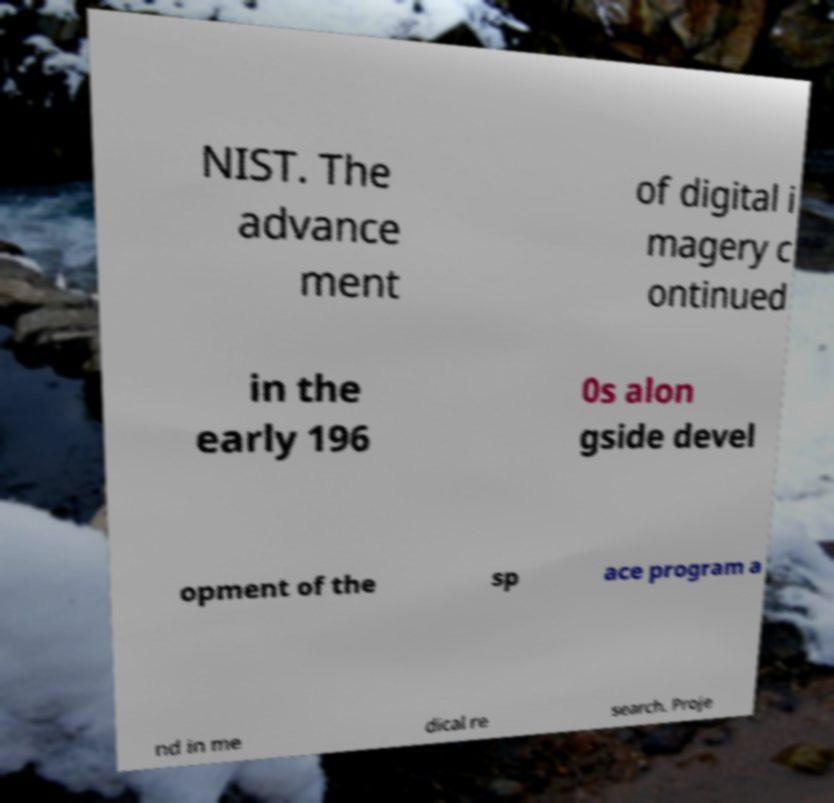Could you assist in decoding the text presented in this image and type it out clearly? NIST. The advance ment of digital i magery c ontinued in the early 196 0s alon gside devel opment of the sp ace program a nd in me dical re search. Proje 